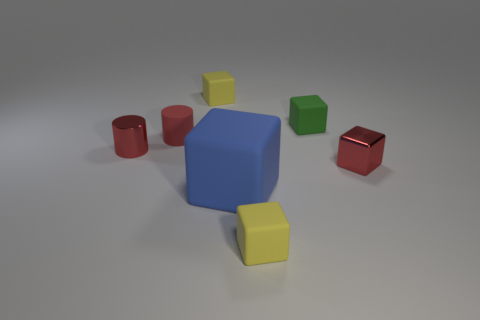Is the size of the red matte cylinder the same as the red block?
Your response must be concise. Yes. Are there the same number of small matte objects to the left of the large matte cube and small metal cylinders in front of the red block?
Give a very brief answer. No. Are any tiny green matte blocks visible?
Your answer should be very brief. Yes. What size is the red thing that is the same shape as the big blue matte thing?
Offer a very short reply. Small. There is a red block behind the large blue object; what size is it?
Your response must be concise. Small. Is the number of small red metallic cubes behind the tiny red block greater than the number of tiny yellow things?
Provide a short and direct response. No. There is a big rubber thing; what shape is it?
Offer a very short reply. Cube. There is a small metallic thing that is to the left of the tiny metal block; is its color the same as the block that is to the right of the small green object?
Provide a succinct answer. Yes. Is the tiny green object the same shape as the tiny red matte object?
Your answer should be compact. No. Is there anything else that is the same shape as the big object?
Provide a succinct answer. Yes. 